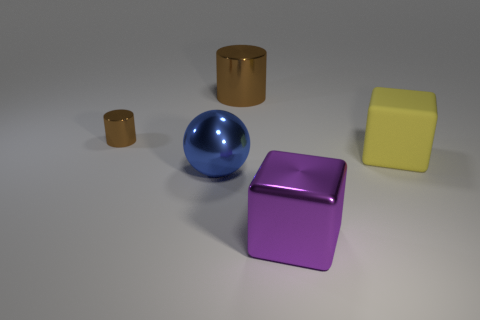Add 2 small green metallic cylinders. How many objects exist? 7 Subtract 0 blue cubes. How many objects are left? 5 Subtract all cubes. How many objects are left? 3 Subtract 1 blocks. How many blocks are left? 1 Subtract all gray spheres. Subtract all cyan cylinders. How many spheres are left? 1 Subtract all gray cubes. How many gray balls are left? 0 Subtract all big purple metal cylinders. Subtract all purple objects. How many objects are left? 4 Add 3 small brown metallic cylinders. How many small brown metallic cylinders are left? 4 Add 1 yellow metal balls. How many yellow metal balls exist? 1 